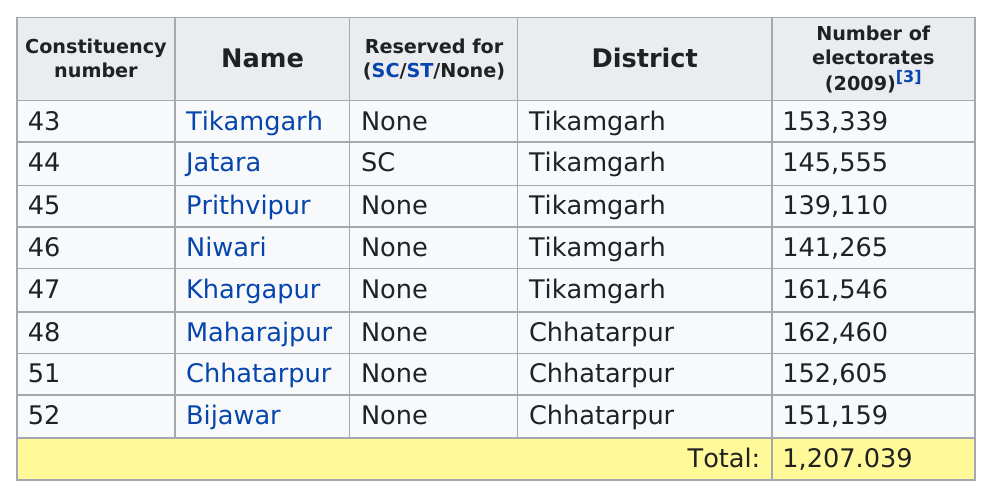Give some essential details in this illustration. In the Chhatarpur district, there are 152,605 electorates. Tikamgarh district has the greatest total number of electorates out of all the districts. I name Prithvipur as a constituency that has a population of 139,110 eligible voters. There are 2 districts. Maharajpur has the most electorates out of all the listed segments, as per the information provided. 